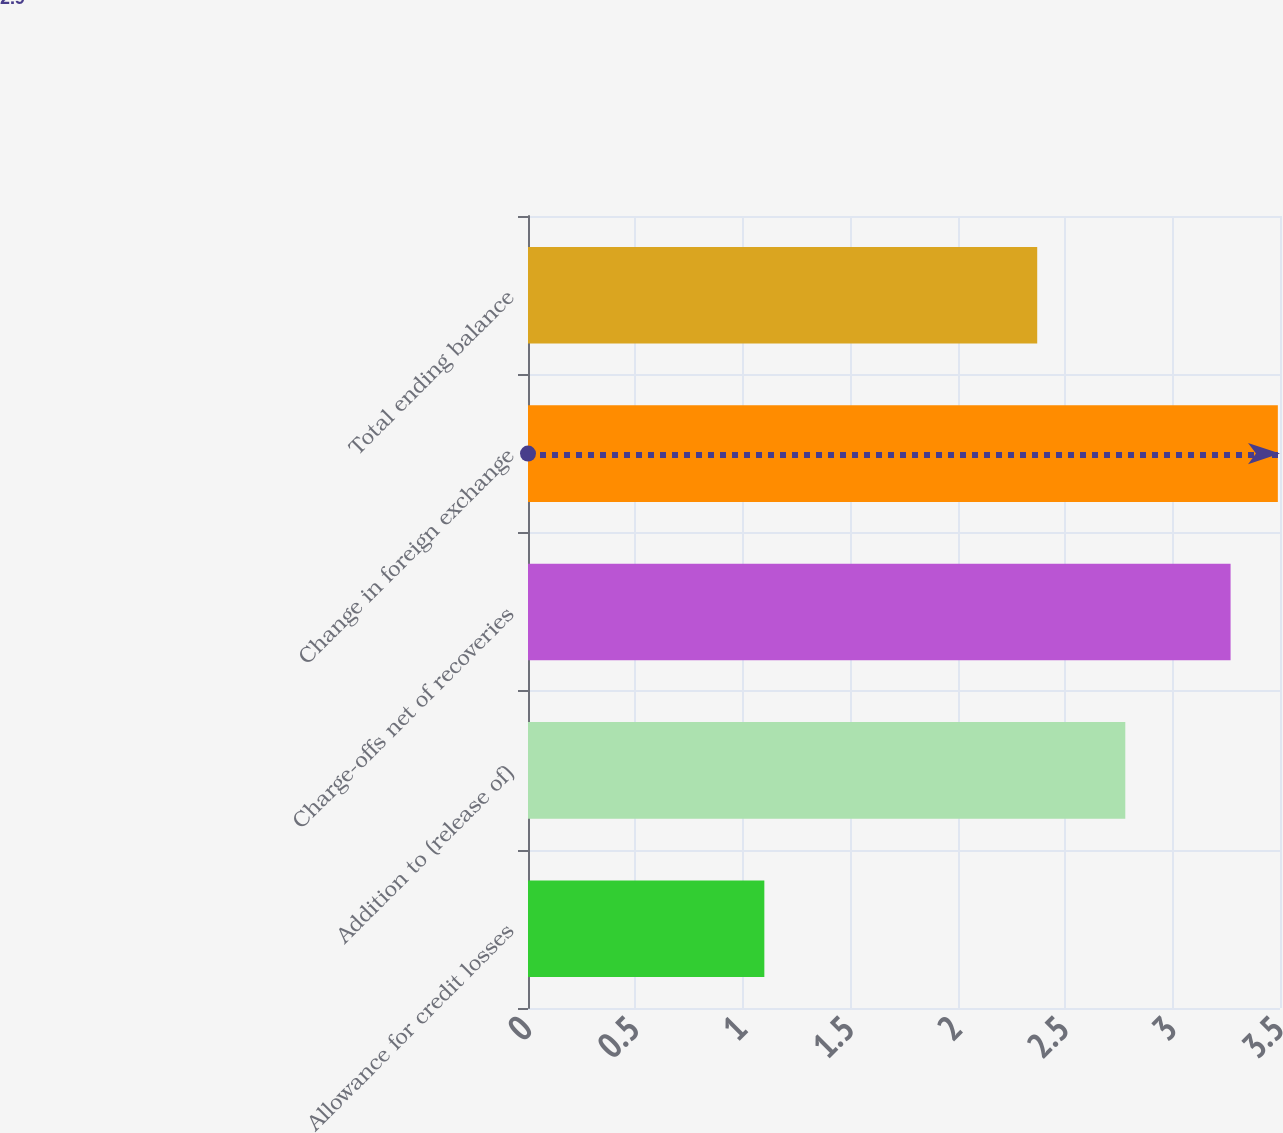<chart> <loc_0><loc_0><loc_500><loc_500><bar_chart><fcel>Allowance for credit losses<fcel>Addition to (release of)<fcel>Charge-offs net of recoveries<fcel>Change in foreign exchange<fcel>Total ending balance<nl><fcel>1.1<fcel>2.78<fcel>3.27<fcel>3.49<fcel>2.37<nl></chart> 